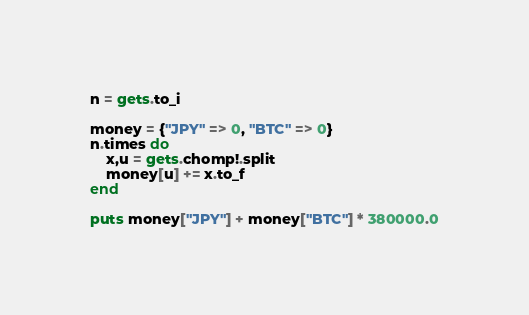Convert code to text. <code><loc_0><loc_0><loc_500><loc_500><_Ruby_>n = gets.to_i

money = {"JPY" => 0, "BTC" => 0}
n.times do
    x,u = gets.chomp!.split
    money[u] += x.to_f
end

puts money["JPY"] + money["BTC"] * 380000.0</code> 